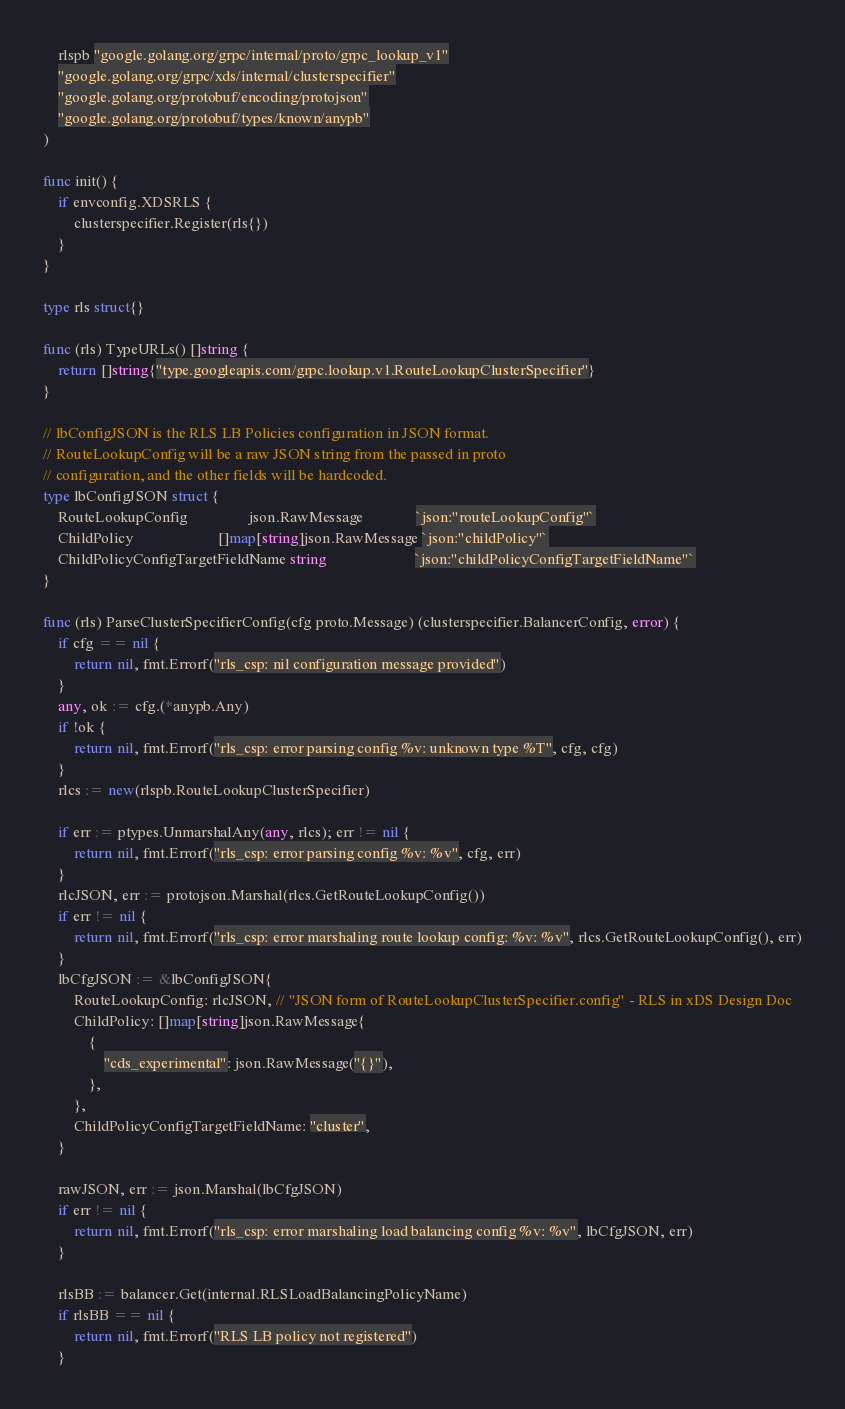<code> <loc_0><loc_0><loc_500><loc_500><_Go_>	rlspb "google.golang.org/grpc/internal/proto/grpc_lookup_v1"
	"google.golang.org/grpc/xds/internal/clusterspecifier"
	"google.golang.org/protobuf/encoding/protojson"
	"google.golang.org/protobuf/types/known/anypb"
)

func init() {
	if envconfig.XDSRLS {
		clusterspecifier.Register(rls{})
	}
}

type rls struct{}

func (rls) TypeURLs() []string {
	return []string{"type.googleapis.com/grpc.lookup.v1.RouteLookupClusterSpecifier"}
}

// lbConfigJSON is the RLS LB Policies configuration in JSON format.
// RouteLookupConfig will be a raw JSON string from the passed in proto
// configuration, and the other fields will be hardcoded.
type lbConfigJSON struct {
	RouteLookupConfig                json.RawMessage              `json:"routeLookupConfig"`
	ChildPolicy                      []map[string]json.RawMessage `json:"childPolicy"`
	ChildPolicyConfigTargetFieldName string                       `json:"childPolicyConfigTargetFieldName"`
}

func (rls) ParseClusterSpecifierConfig(cfg proto.Message) (clusterspecifier.BalancerConfig, error) {
	if cfg == nil {
		return nil, fmt.Errorf("rls_csp: nil configuration message provided")
	}
	any, ok := cfg.(*anypb.Any)
	if !ok {
		return nil, fmt.Errorf("rls_csp: error parsing config %v: unknown type %T", cfg, cfg)
	}
	rlcs := new(rlspb.RouteLookupClusterSpecifier)

	if err := ptypes.UnmarshalAny(any, rlcs); err != nil {
		return nil, fmt.Errorf("rls_csp: error parsing config %v: %v", cfg, err)
	}
	rlcJSON, err := protojson.Marshal(rlcs.GetRouteLookupConfig())
	if err != nil {
		return nil, fmt.Errorf("rls_csp: error marshaling route lookup config: %v: %v", rlcs.GetRouteLookupConfig(), err)
	}
	lbCfgJSON := &lbConfigJSON{
		RouteLookupConfig: rlcJSON, // "JSON form of RouteLookupClusterSpecifier.config" - RLS in xDS Design Doc
		ChildPolicy: []map[string]json.RawMessage{
			{
				"cds_experimental": json.RawMessage("{}"),
			},
		},
		ChildPolicyConfigTargetFieldName: "cluster",
	}

	rawJSON, err := json.Marshal(lbCfgJSON)
	if err != nil {
		return nil, fmt.Errorf("rls_csp: error marshaling load balancing config %v: %v", lbCfgJSON, err)
	}

	rlsBB := balancer.Get(internal.RLSLoadBalancingPolicyName)
	if rlsBB == nil {
		return nil, fmt.Errorf("RLS LB policy not registered")
	}</code> 